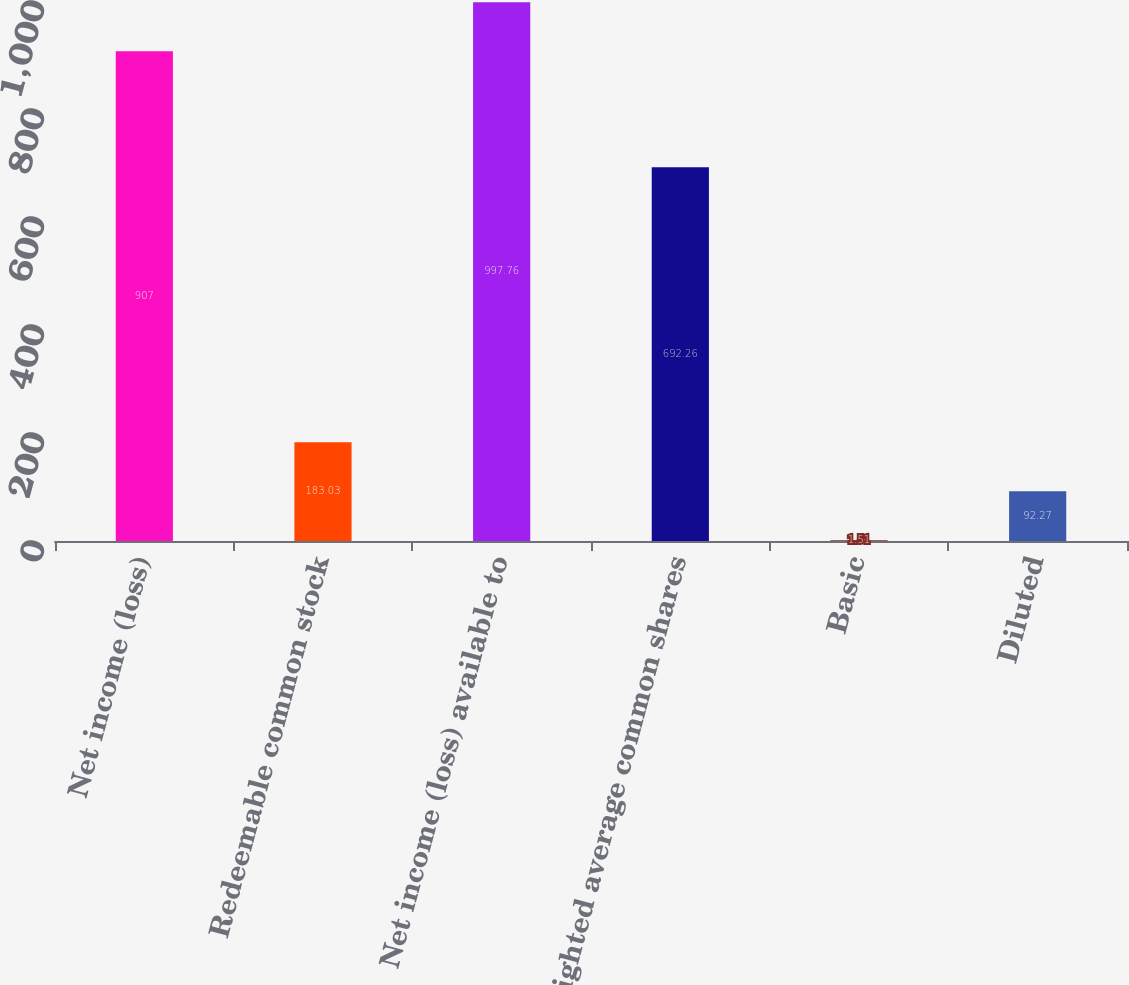Convert chart. <chart><loc_0><loc_0><loc_500><loc_500><bar_chart><fcel>Net income (loss)<fcel>Redeemable common stock<fcel>Net income (loss) available to<fcel>Weighted average common shares<fcel>Basic<fcel>Diluted<nl><fcel>907<fcel>183.03<fcel>997.76<fcel>692.26<fcel>1.51<fcel>92.27<nl></chart> 